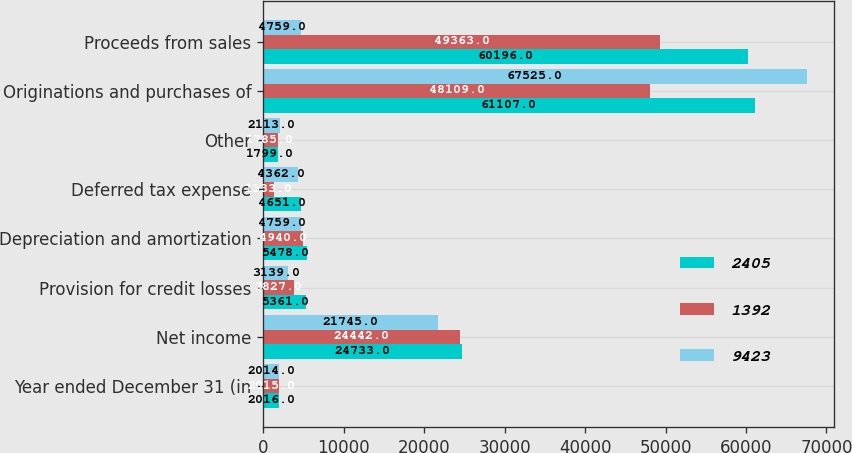<chart> <loc_0><loc_0><loc_500><loc_500><stacked_bar_chart><ecel><fcel>Year ended December 31 (in<fcel>Net income<fcel>Provision for credit losses<fcel>Depreciation and amortization<fcel>Deferred tax expense<fcel>Other<fcel>Originations and purchases of<fcel>Proceeds from sales<nl><fcel>2405<fcel>2016<fcel>24733<fcel>5361<fcel>5478<fcel>4651<fcel>1799<fcel>61107<fcel>60196<nl><fcel>1392<fcel>2015<fcel>24442<fcel>3827<fcel>4940<fcel>1333<fcel>1785<fcel>48109<fcel>49363<nl><fcel>9423<fcel>2014<fcel>21745<fcel>3139<fcel>4759<fcel>4362<fcel>2113<fcel>67525<fcel>4759<nl></chart> 